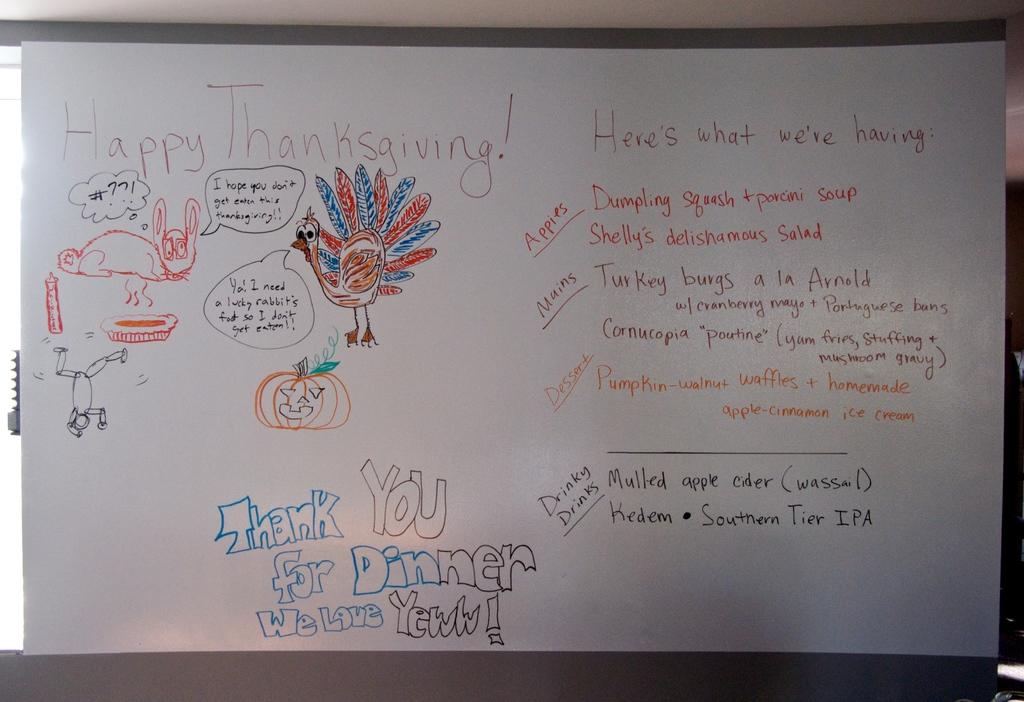What kind of party is being planned on the board?
Provide a succinct answer. Thanksgiving. What type of squash are they having?
Your response must be concise. Dumpling. 